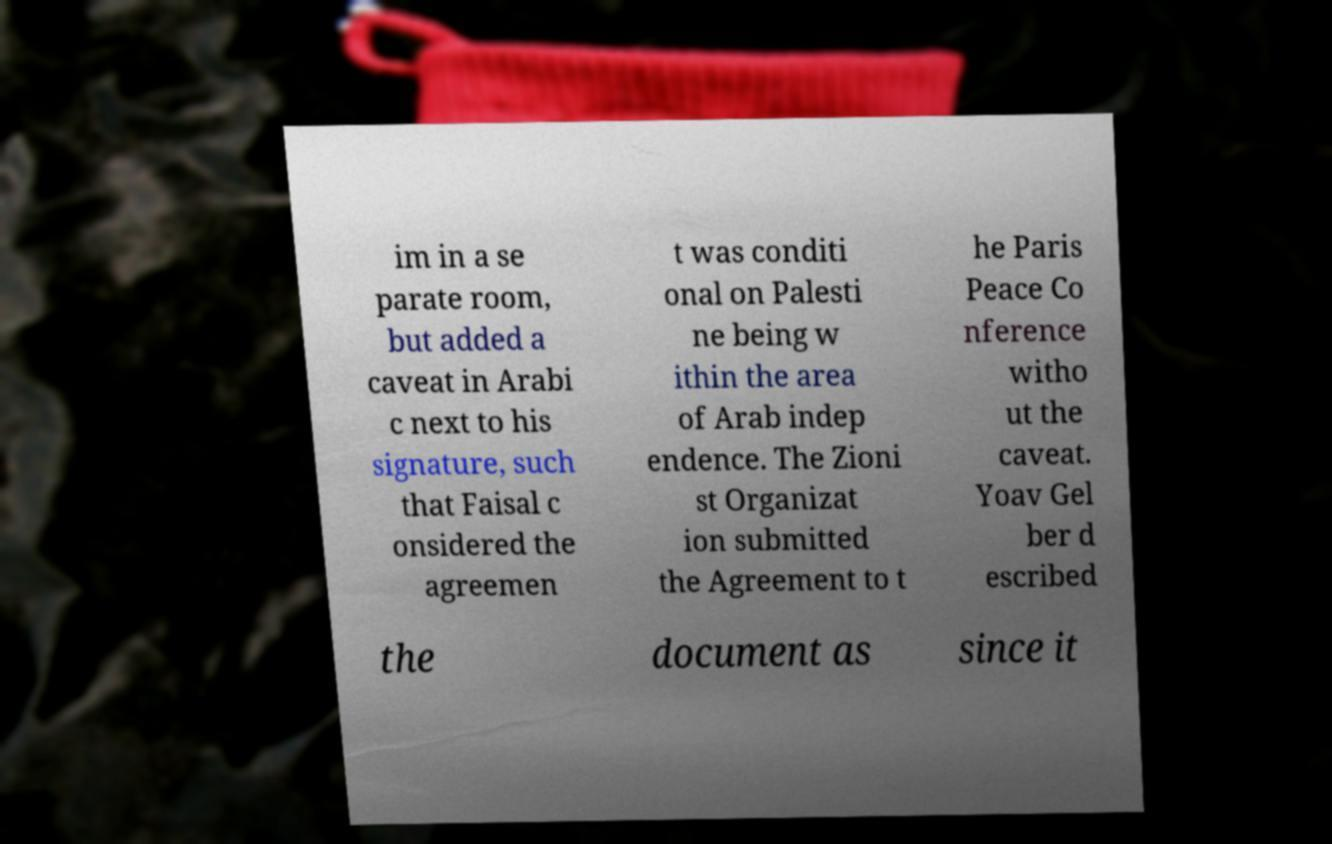There's text embedded in this image that I need extracted. Can you transcribe it verbatim? im in a se parate room, but added a caveat in Arabi c next to his signature, such that Faisal c onsidered the agreemen t was conditi onal on Palesti ne being w ithin the area of Arab indep endence. The Zioni st Organizat ion submitted the Agreement to t he Paris Peace Co nference witho ut the caveat. Yoav Gel ber d escribed the document as since it 